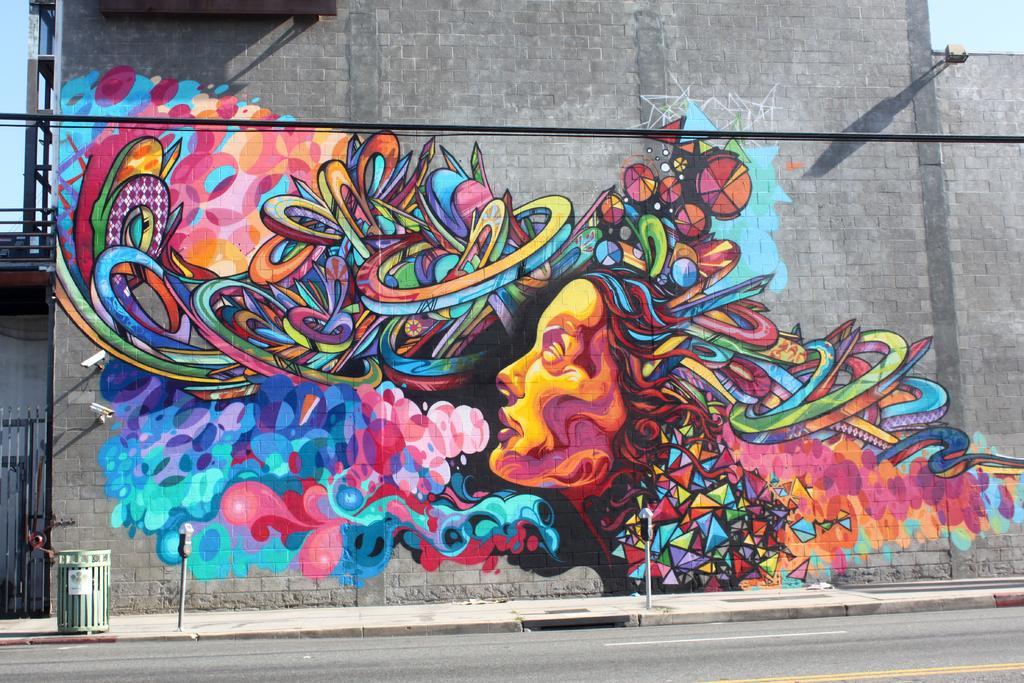Could you give a brief overview of what you see in this image? In the foreground of this image, there is a graffiti painting on the wall. On the bottom, there is a road and there is a dustbin on the side path. In the background, there is the sky. 